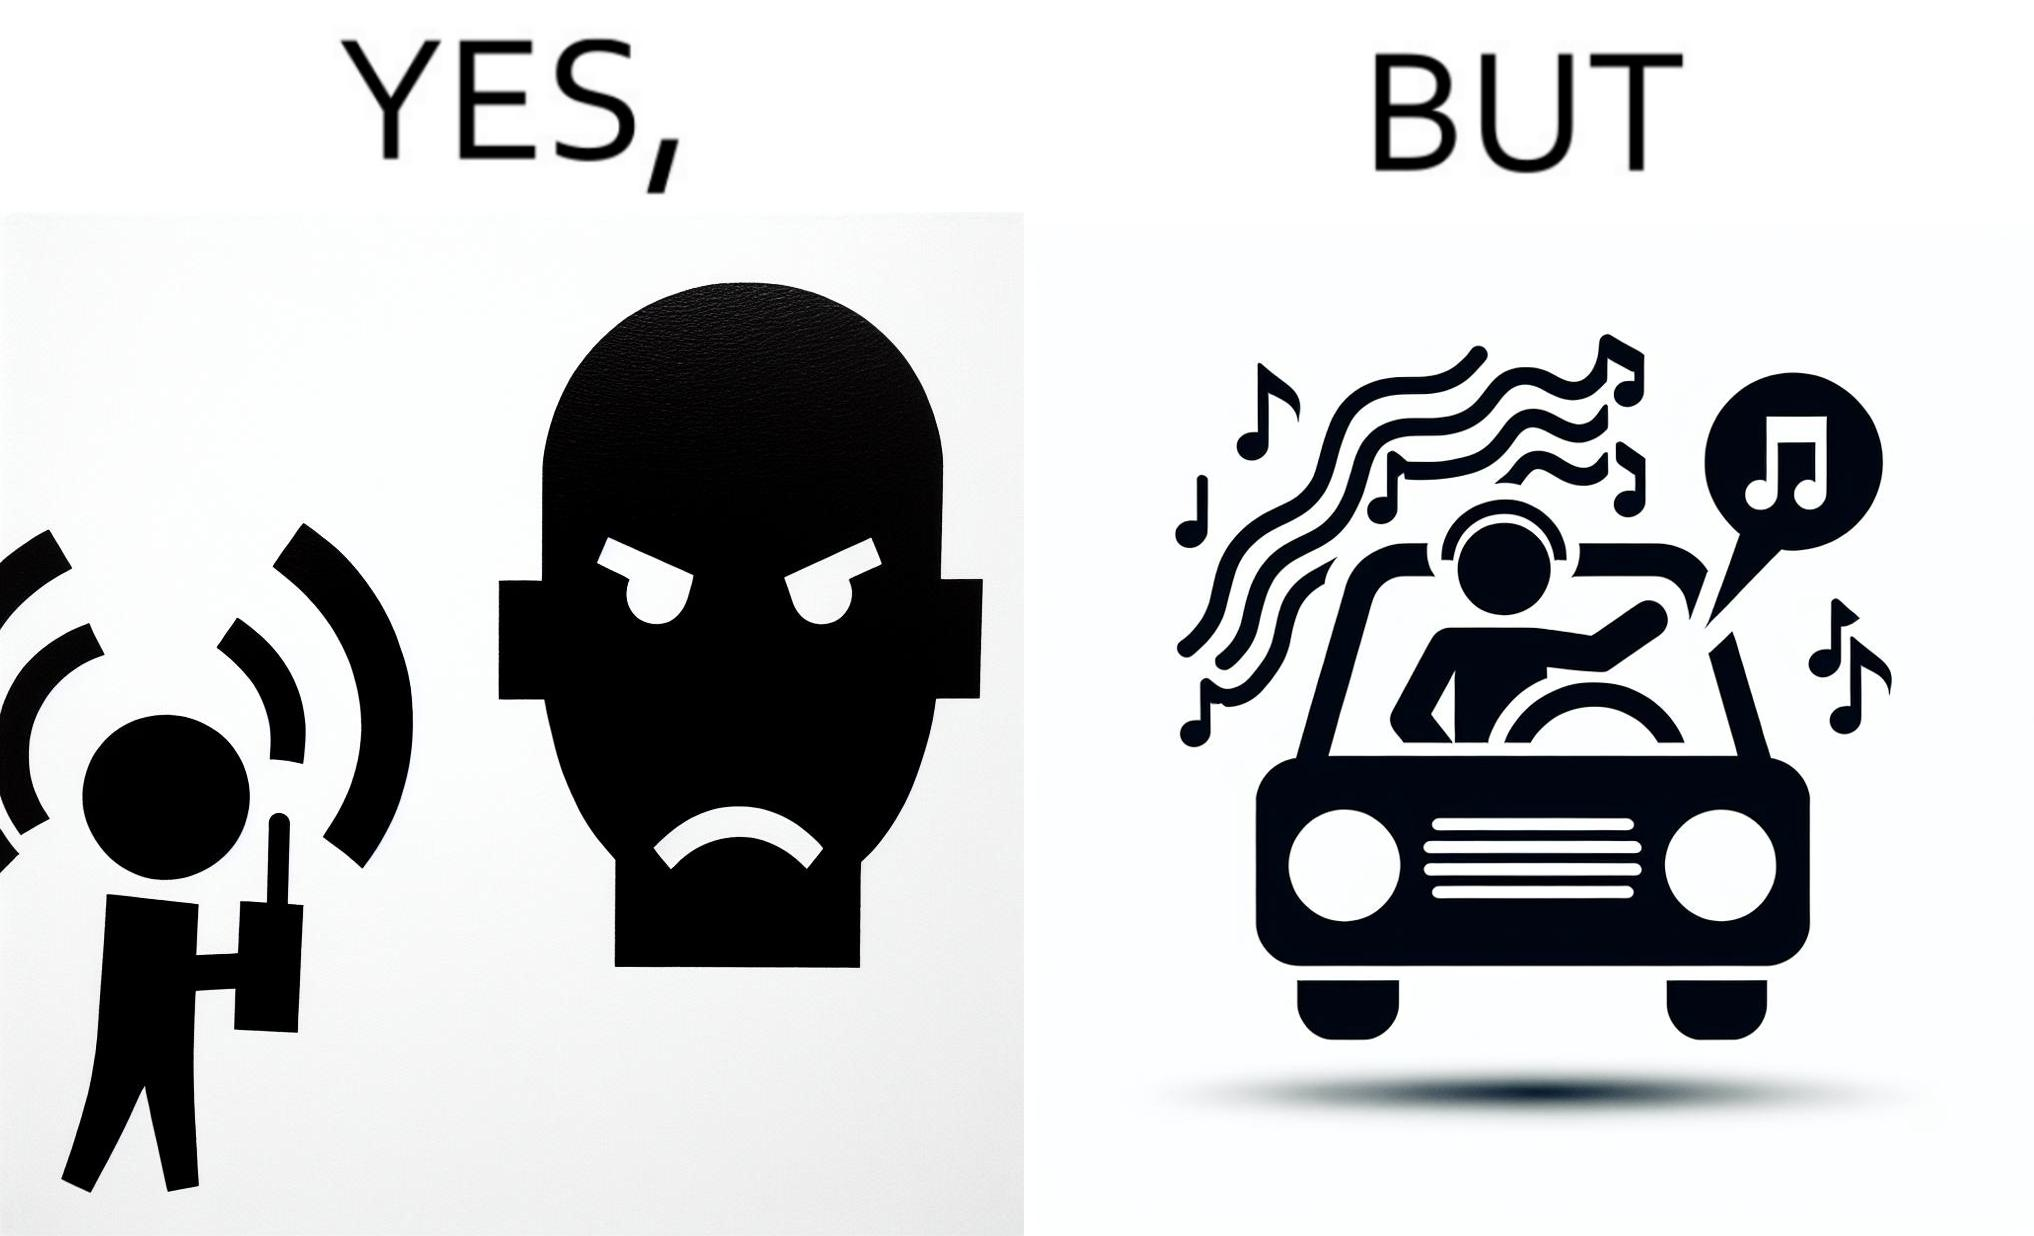Would you classify this image as satirical? Yes, this image is satirical. 